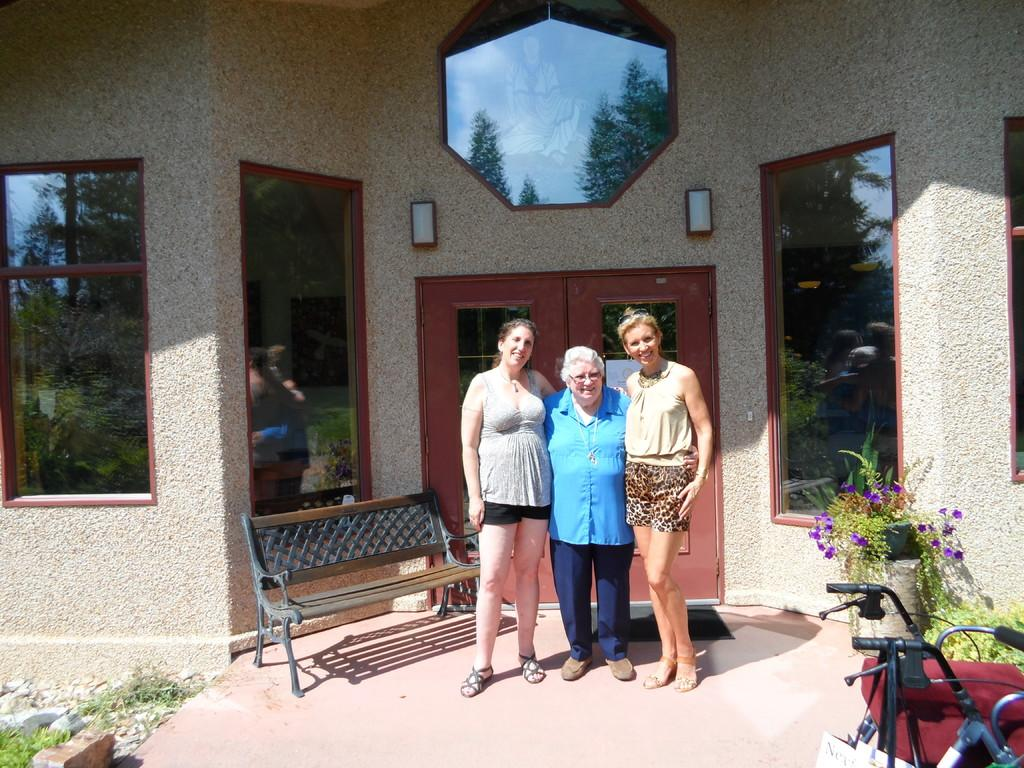How many women are present in the image? There are three women in the image. What are the women doing in the image? The women are standing at a door. What can be seen on the left side of the image? There is a bench on the left side of the image. What type of vegetation is present in the image? There are plants in the image. What mode of transportation can be seen in the image? There is a bicycle in the image. What is visible in the background of the image? There is a wall visible in the background of the image. How many pins are attached to the bicycle in the image? There are no pins visible on the bicycle in the image. What type of cord is being used by the women to hold the door open? There is no cord present in the image, and the women are not holding the door open. 